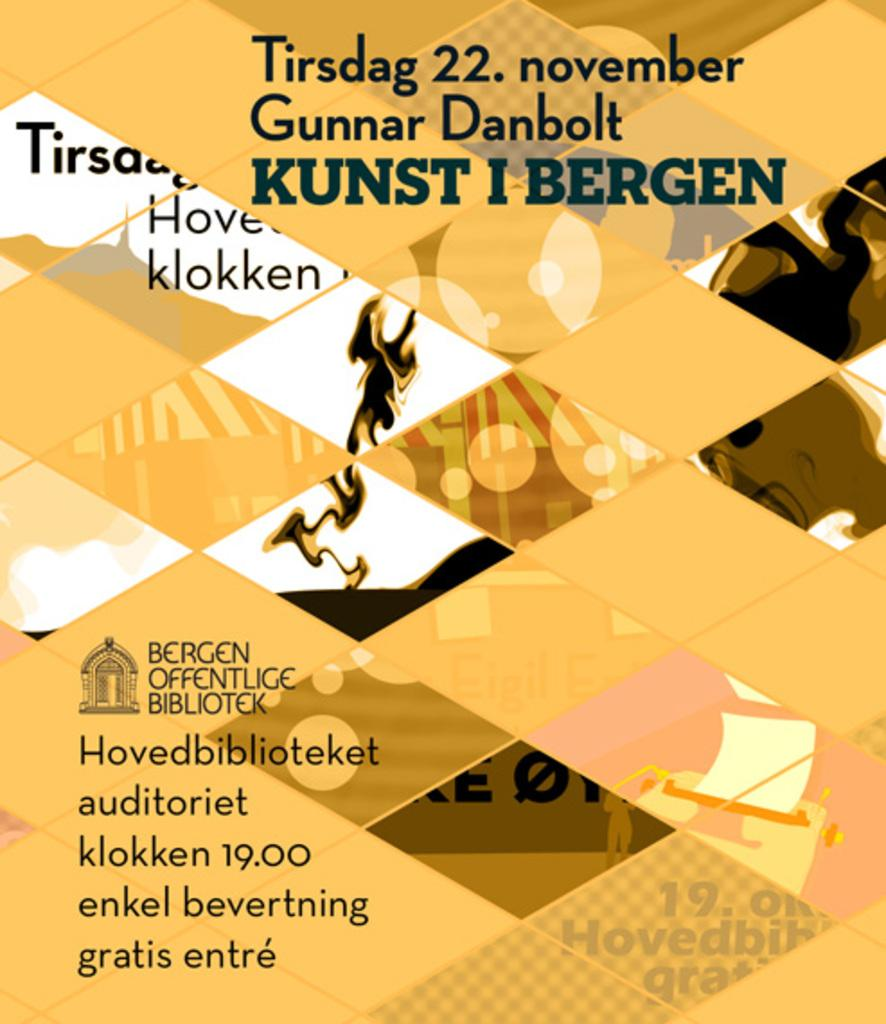<image>
Share a concise interpretation of the image provided. A yellow colored paper with German writing on it that mentions the date of November 22. 